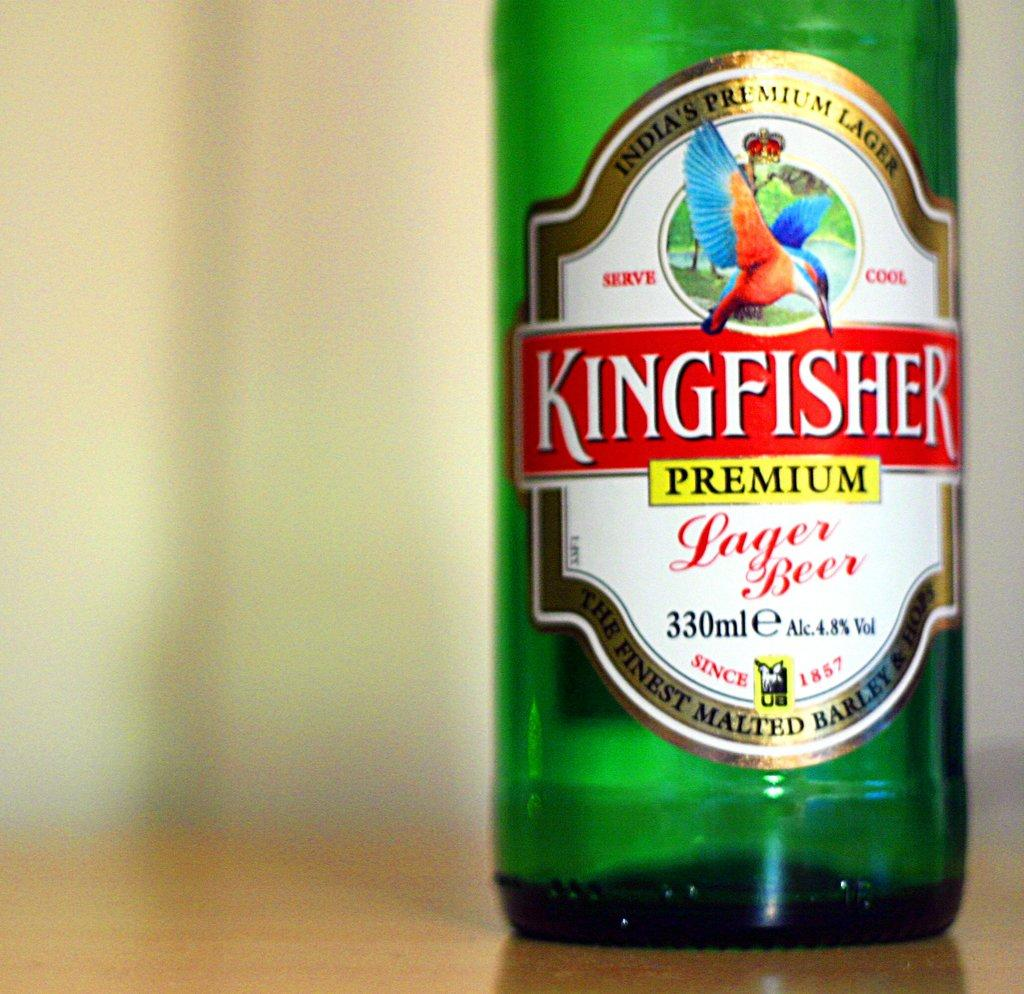What color is the bottle that is visible in the image? The bottle in the image is green. What is on the green bottle? The green bottle has a label. Where is the green bottle located in the image? The green bottle is on a surface. What is the name of the company that produces the cakes in the image? There are no cakes or company mentioned in the image; it only features a green bottle with a label. 